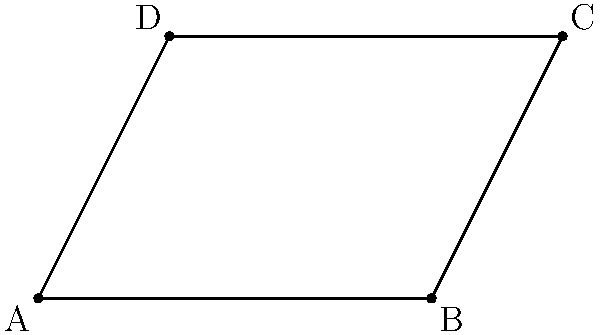At a Lucianoz concert in Stockholm, the stage is set up in the shape of a parallelogram. Three vertices of the parallelogram are known: A(0,0), B(6,0), and C(8,4). Find the coordinates of the fourth vertex, D, to complete the stage setup. To find the coordinates of the fourth vertex D in a parallelogram ABCD, we can follow these steps:

1) In a parallelogram, opposite sides are parallel and equal. This means that AD is parallel and equal to BC.

2) We can use the property that the diagonals of a parallelogram bisect each other. This means that the midpoint of AC is the same as the midpoint of BD.

3) Let's call the coordinates of D (x,y).

4) The midpoint of AC is:
   $(\frac{0+8}{2}, \frac{0+4}{2}) = (4,2)$

5) This should be equal to the midpoint of BD:
   $(\frac{6+x}{2}, \frac{0+y}{2}) = (4,2)$

6) From this, we can set up two equations:
   $\frac{6+x}{2} = 4$ and $\frac{0+y}{2} = 2$

7) Solving these:
   $6+x = 8$, so $x = 2$
   $y = 4$

8) Therefore, the coordinates of D are (2,4).

9) We can verify this by noting that D is the point that completes the parallelogram: it's 6 units to the left and 4 units up from C, just as B is 6 units to the right and 4 units down from C.
Answer: D(2,4) 